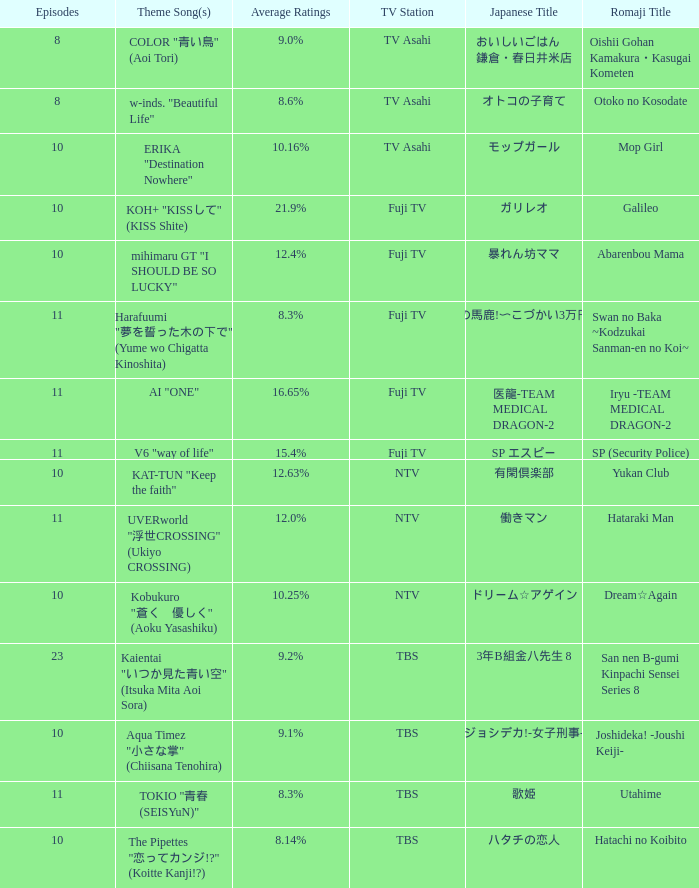What is the Theme Song of Iryu -Team Medical Dragon-2? AI "ONE". 